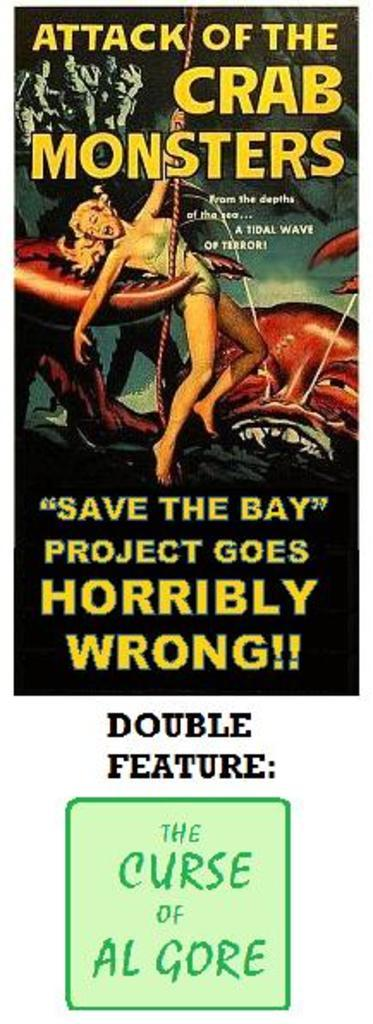<image>
Offer a succinct explanation of the picture presented. A political poster which details The Curse of Al Gore. 